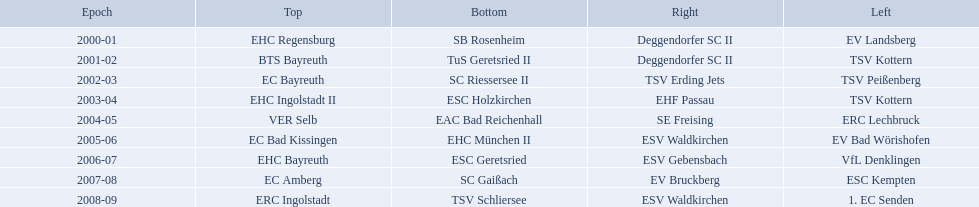Which teams won the north in their respective years? 2000-01, EHC Regensburg, BTS Bayreuth, EC Bayreuth, EHC Ingolstadt II, VER Selb, EC Bad Kissingen, EHC Bayreuth, EC Amberg, ERC Ingolstadt. Which one only won in 2000-01? EHC Regensburg. Which teams played in the north? EHC Regensburg, BTS Bayreuth, EC Bayreuth, EHC Ingolstadt II, VER Selb, EC Bad Kissingen, EHC Bayreuth, EC Amberg, ERC Ingolstadt. Of these teams, which played during 2000-2001? EHC Regensburg. Which teams have won in the bavarian ice hockey leagues between 2000 and 2009? EHC Regensburg, SB Rosenheim, Deggendorfer SC II, EV Landsberg, BTS Bayreuth, TuS Geretsried II, TSV Kottern, EC Bayreuth, SC Riessersee II, TSV Erding Jets, TSV Peißenberg, EHC Ingolstadt II, ESC Holzkirchen, EHF Passau, TSV Kottern, VER Selb, EAC Bad Reichenhall, SE Freising, ERC Lechbruck, EC Bad Kissingen, EHC München II, ESV Waldkirchen, EV Bad Wörishofen, EHC Bayreuth, ESC Geretsried, ESV Gebensbach, VfL Denklingen, EC Amberg, SC Gaißach, EV Bruckberg, ESC Kempten, ERC Ingolstadt, TSV Schliersee, ESV Waldkirchen, 1. EC Senden. Which of these winning teams have won the north? EHC Regensburg, BTS Bayreuth, EC Bayreuth, EHC Ingolstadt II, VER Selb, EC Bad Kissingen, EHC Bayreuth, EC Amberg, ERC Ingolstadt. Which of the teams that won the north won in the 2000/2001 season? EHC Regensburg. 